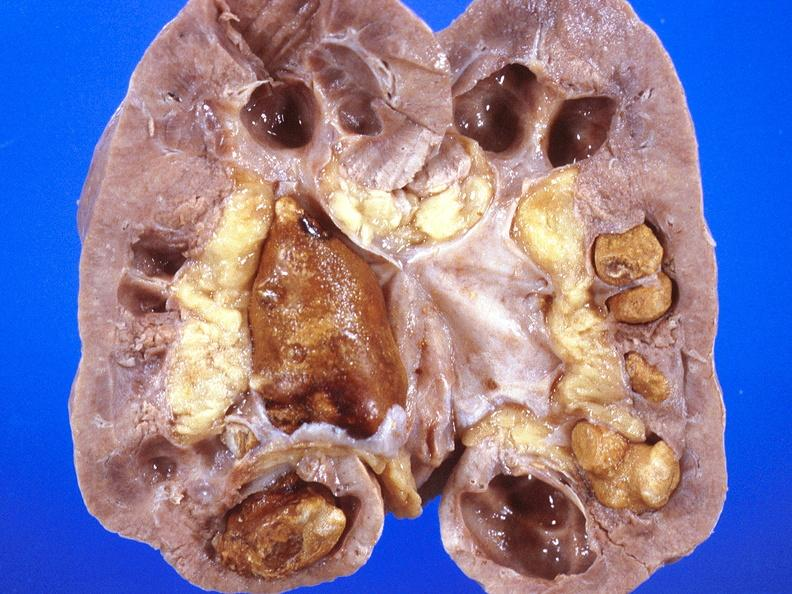does bone, skull show renal pelvis, staghorn calculi?
Answer the question using a single word or phrase. No 